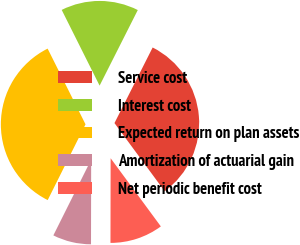Convert chart to OTSL. <chart><loc_0><loc_0><loc_500><loc_500><pie_chart><fcel>Service cost<fcel>Interest cost<fcel>Expected return on plan assets<fcel>Amortization of actuarial gain<fcel>Net periodic benefit cost<nl><fcel>32.45%<fcel>14.83%<fcel>35.24%<fcel>7.34%<fcel>10.13%<nl></chart> 